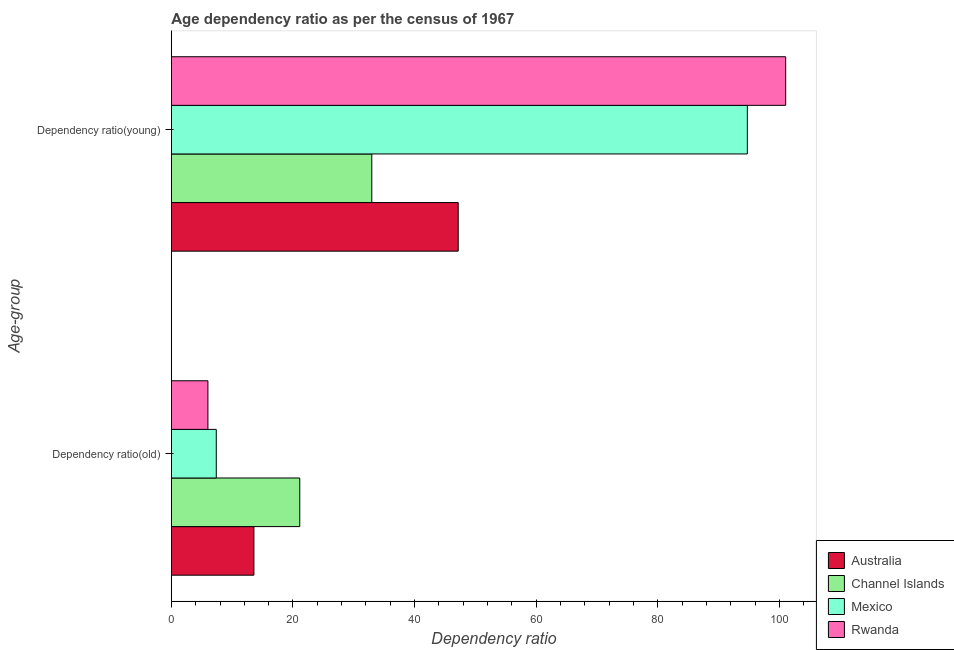Are the number of bars per tick equal to the number of legend labels?
Offer a terse response. Yes. How many bars are there on the 1st tick from the top?
Make the answer very short. 4. What is the label of the 1st group of bars from the top?
Offer a terse response. Dependency ratio(young). What is the age dependency ratio(old) in Rwanda?
Provide a succinct answer. 6.01. Across all countries, what is the maximum age dependency ratio(young)?
Provide a short and direct response. 101.04. Across all countries, what is the minimum age dependency ratio(old)?
Provide a succinct answer. 6.01. In which country was the age dependency ratio(old) maximum?
Your answer should be very brief. Channel Islands. In which country was the age dependency ratio(old) minimum?
Your answer should be very brief. Rwanda. What is the total age dependency ratio(old) in the graph?
Provide a short and direct response. 48.08. What is the difference between the age dependency ratio(young) in Rwanda and that in Australia?
Give a very brief answer. 53.86. What is the difference between the age dependency ratio(young) in Mexico and the age dependency ratio(old) in Australia?
Your response must be concise. 81.16. What is the average age dependency ratio(old) per country?
Offer a very short reply. 12.02. What is the difference between the age dependency ratio(old) and age dependency ratio(young) in Rwanda?
Ensure brevity in your answer.  -95.03. What is the ratio of the age dependency ratio(young) in Channel Islands to that in Australia?
Make the answer very short. 0.7. In how many countries, is the age dependency ratio(old) greater than the average age dependency ratio(old) taken over all countries?
Make the answer very short. 2. What does the 4th bar from the top in Dependency ratio(young) represents?
Make the answer very short. Australia. What does the 1st bar from the bottom in Dependency ratio(old) represents?
Make the answer very short. Australia. How many bars are there?
Make the answer very short. 8. What is the difference between two consecutive major ticks on the X-axis?
Make the answer very short. 20. Does the graph contain any zero values?
Provide a short and direct response. No. Does the graph contain grids?
Your response must be concise. No. What is the title of the graph?
Your response must be concise. Age dependency ratio as per the census of 1967. Does "France" appear as one of the legend labels in the graph?
Your answer should be compact. No. What is the label or title of the X-axis?
Offer a very short reply. Dependency ratio. What is the label or title of the Y-axis?
Ensure brevity in your answer.  Age-group. What is the Dependency ratio of Australia in Dependency ratio(old)?
Offer a terse response. 13.57. What is the Dependency ratio in Channel Islands in Dependency ratio(old)?
Your response must be concise. 21.12. What is the Dependency ratio of Mexico in Dependency ratio(old)?
Your response must be concise. 7.38. What is the Dependency ratio of Rwanda in Dependency ratio(old)?
Make the answer very short. 6.01. What is the Dependency ratio in Australia in Dependency ratio(young)?
Your answer should be compact. 47.18. What is the Dependency ratio of Channel Islands in Dependency ratio(young)?
Provide a succinct answer. 32.96. What is the Dependency ratio in Mexico in Dependency ratio(young)?
Your answer should be very brief. 94.73. What is the Dependency ratio of Rwanda in Dependency ratio(young)?
Ensure brevity in your answer.  101.04. Across all Age-group, what is the maximum Dependency ratio of Australia?
Provide a short and direct response. 47.18. Across all Age-group, what is the maximum Dependency ratio of Channel Islands?
Keep it short and to the point. 32.96. Across all Age-group, what is the maximum Dependency ratio in Mexico?
Your response must be concise. 94.73. Across all Age-group, what is the maximum Dependency ratio in Rwanda?
Give a very brief answer. 101.04. Across all Age-group, what is the minimum Dependency ratio in Australia?
Provide a short and direct response. 13.57. Across all Age-group, what is the minimum Dependency ratio in Channel Islands?
Offer a very short reply. 21.12. Across all Age-group, what is the minimum Dependency ratio of Mexico?
Give a very brief answer. 7.38. Across all Age-group, what is the minimum Dependency ratio in Rwanda?
Offer a terse response. 6.01. What is the total Dependency ratio in Australia in the graph?
Your answer should be very brief. 60.75. What is the total Dependency ratio in Channel Islands in the graph?
Ensure brevity in your answer.  54.08. What is the total Dependency ratio of Mexico in the graph?
Provide a short and direct response. 102.11. What is the total Dependency ratio in Rwanda in the graph?
Offer a terse response. 107.05. What is the difference between the Dependency ratio in Australia in Dependency ratio(old) and that in Dependency ratio(young)?
Offer a very short reply. -33.6. What is the difference between the Dependency ratio of Channel Islands in Dependency ratio(old) and that in Dependency ratio(young)?
Make the answer very short. -11.85. What is the difference between the Dependency ratio in Mexico in Dependency ratio(old) and that in Dependency ratio(young)?
Your answer should be very brief. -87.35. What is the difference between the Dependency ratio in Rwanda in Dependency ratio(old) and that in Dependency ratio(young)?
Give a very brief answer. -95.03. What is the difference between the Dependency ratio in Australia in Dependency ratio(old) and the Dependency ratio in Channel Islands in Dependency ratio(young)?
Make the answer very short. -19.39. What is the difference between the Dependency ratio of Australia in Dependency ratio(old) and the Dependency ratio of Mexico in Dependency ratio(young)?
Provide a short and direct response. -81.16. What is the difference between the Dependency ratio of Australia in Dependency ratio(old) and the Dependency ratio of Rwanda in Dependency ratio(young)?
Provide a short and direct response. -87.46. What is the difference between the Dependency ratio of Channel Islands in Dependency ratio(old) and the Dependency ratio of Mexico in Dependency ratio(young)?
Make the answer very short. -73.62. What is the difference between the Dependency ratio of Channel Islands in Dependency ratio(old) and the Dependency ratio of Rwanda in Dependency ratio(young)?
Offer a terse response. -79.92. What is the difference between the Dependency ratio of Mexico in Dependency ratio(old) and the Dependency ratio of Rwanda in Dependency ratio(young)?
Offer a very short reply. -93.65. What is the average Dependency ratio in Australia per Age-group?
Ensure brevity in your answer.  30.37. What is the average Dependency ratio in Channel Islands per Age-group?
Your answer should be compact. 27.04. What is the average Dependency ratio in Mexico per Age-group?
Make the answer very short. 51.06. What is the average Dependency ratio of Rwanda per Age-group?
Your answer should be compact. 53.52. What is the difference between the Dependency ratio in Australia and Dependency ratio in Channel Islands in Dependency ratio(old)?
Your answer should be compact. -7.54. What is the difference between the Dependency ratio of Australia and Dependency ratio of Mexico in Dependency ratio(old)?
Keep it short and to the point. 6.19. What is the difference between the Dependency ratio of Australia and Dependency ratio of Rwanda in Dependency ratio(old)?
Give a very brief answer. 7.56. What is the difference between the Dependency ratio in Channel Islands and Dependency ratio in Mexico in Dependency ratio(old)?
Offer a very short reply. 13.73. What is the difference between the Dependency ratio in Channel Islands and Dependency ratio in Rwanda in Dependency ratio(old)?
Provide a succinct answer. 15.11. What is the difference between the Dependency ratio of Mexico and Dependency ratio of Rwanda in Dependency ratio(old)?
Your answer should be compact. 1.37. What is the difference between the Dependency ratio in Australia and Dependency ratio in Channel Islands in Dependency ratio(young)?
Make the answer very short. 14.21. What is the difference between the Dependency ratio of Australia and Dependency ratio of Mexico in Dependency ratio(young)?
Provide a succinct answer. -47.55. What is the difference between the Dependency ratio in Australia and Dependency ratio in Rwanda in Dependency ratio(young)?
Your response must be concise. -53.86. What is the difference between the Dependency ratio in Channel Islands and Dependency ratio in Mexico in Dependency ratio(young)?
Your answer should be very brief. -61.77. What is the difference between the Dependency ratio of Channel Islands and Dependency ratio of Rwanda in Dependency ratio(young)?
Your answer should be very brief. -68.08. What is the difference between the Dependency ratio in Mexico and Dependency ratio in Rwanda in Dependency ratio(young)?
Your answer should be very brief. -6.31. What is the ratio of the Dependency ratio of Australia in Dependency ratio(old) to that in Dependency ratio(young)?
Your answer should be compact. 0.29. What is the ratio of the Dependency ratio in Channel Islands in Dependency ratio(old) to that in Dependency ratio(young)?
Ensure brevity in your answer.  0.64. What is the ratio of the Dependency ratio of Mexico in Dependency ratio(old) to that in Dependency ratio(young)?
Ensure brevity in your answer.  0.08. What is the ratio of the Dependency ratio in Rwanda in Dependency ratio(old) to that in Dependency ratio(young)?
Ensure brevity in your answer.  0.06. What is the difference between the highest and the second highest Dependency ratio of Australia?
Make the answer very short. 33.6. What is the difference between the highest and the second highest Dependency ratio of Channel Islands?
Make the answer very short. 11.85. What is the difference between the highest and the second highest Dependency ratio in Mexico?
Give a very brief answer. 87.35. What is the difference between the highest and the second highest Dependency ratio in Rwanda?
Your response must be concise. 95.03. What is the difference between the highest and the lowest Dependency ratio in Australia?
Provide a succinct answer. 33.6. What is the difference between the highest and the lowest Dependency ratio of Channel Islands?
Make the answer very short. 11.85. What is the difference between the highest and the lowest Dependency ratio in Mexico?
Provide a short and direct response. 87.35. What is the difference between the highest and the lowest Dependency ratio of Rwanda?
Ensure brevity in your answer.  95.03. 